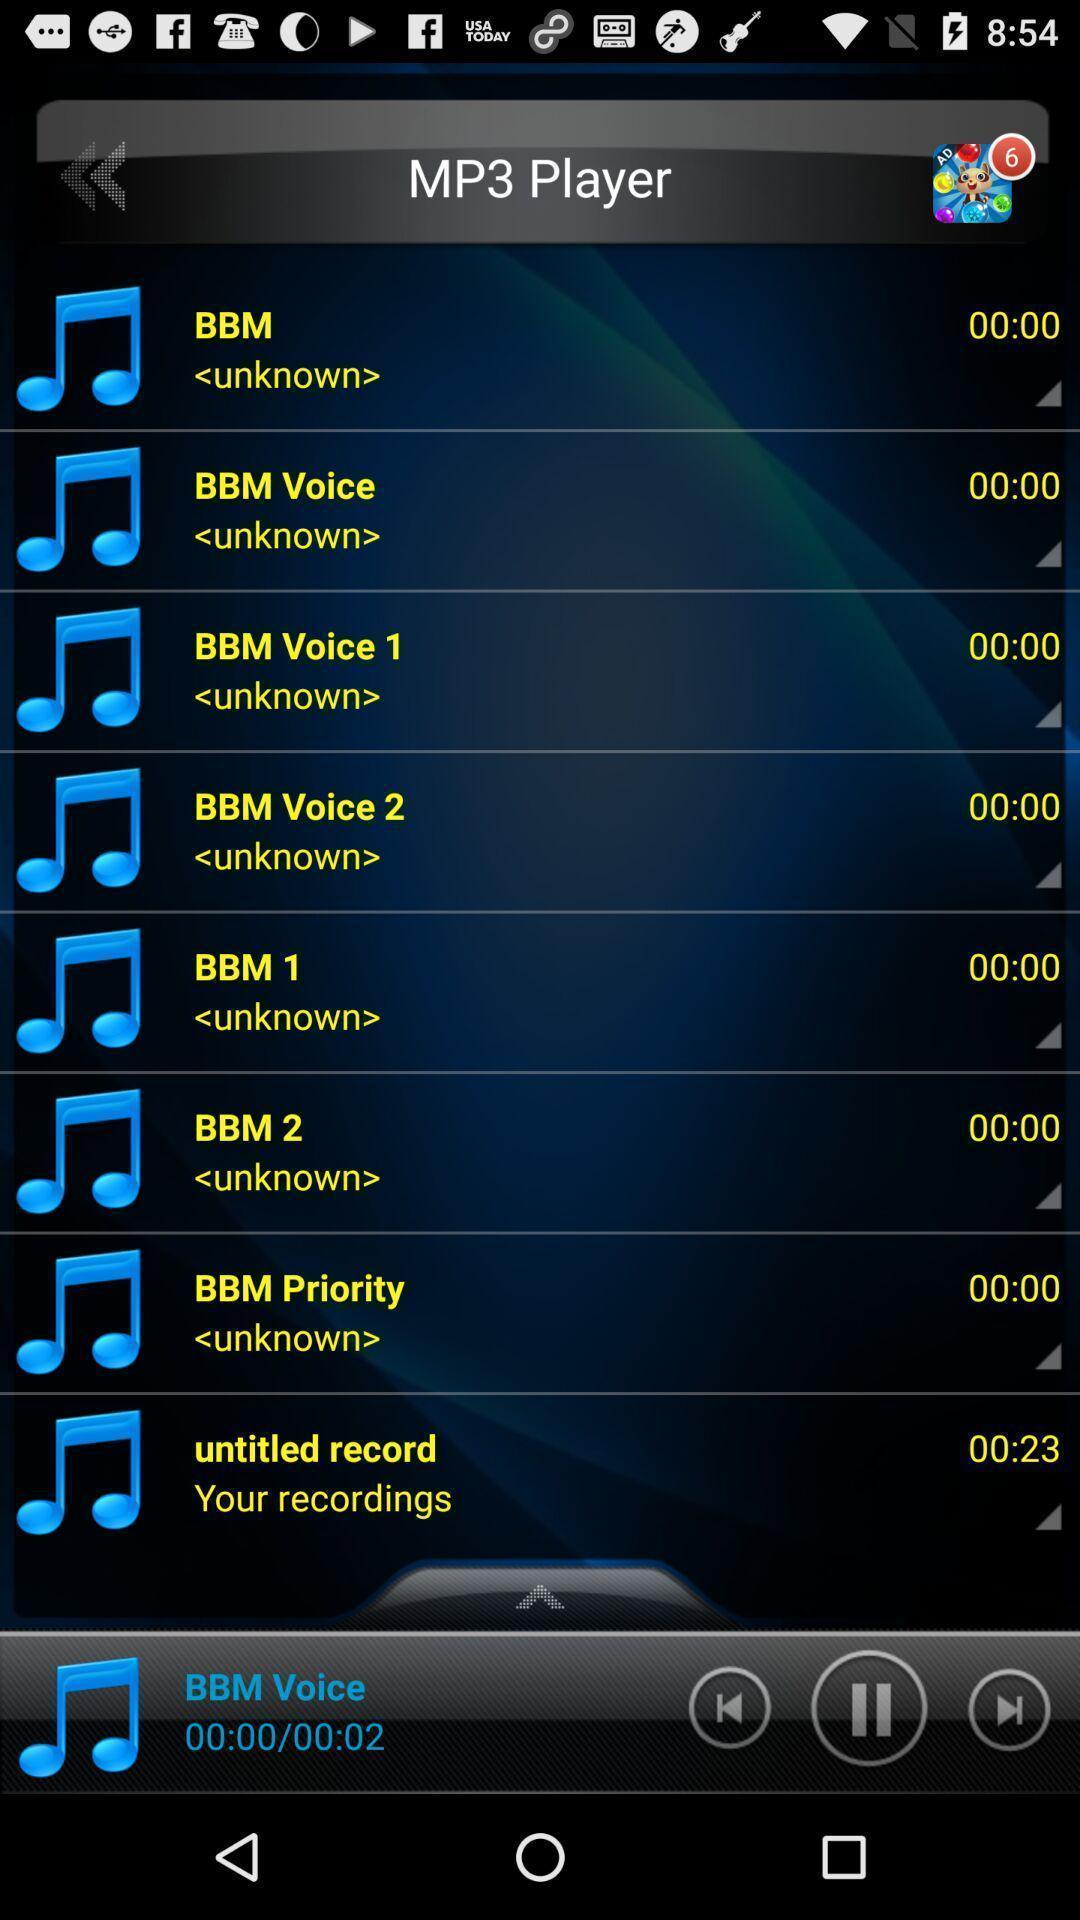Tell me what you see in this picture. Screen shows list of records in a music app. 